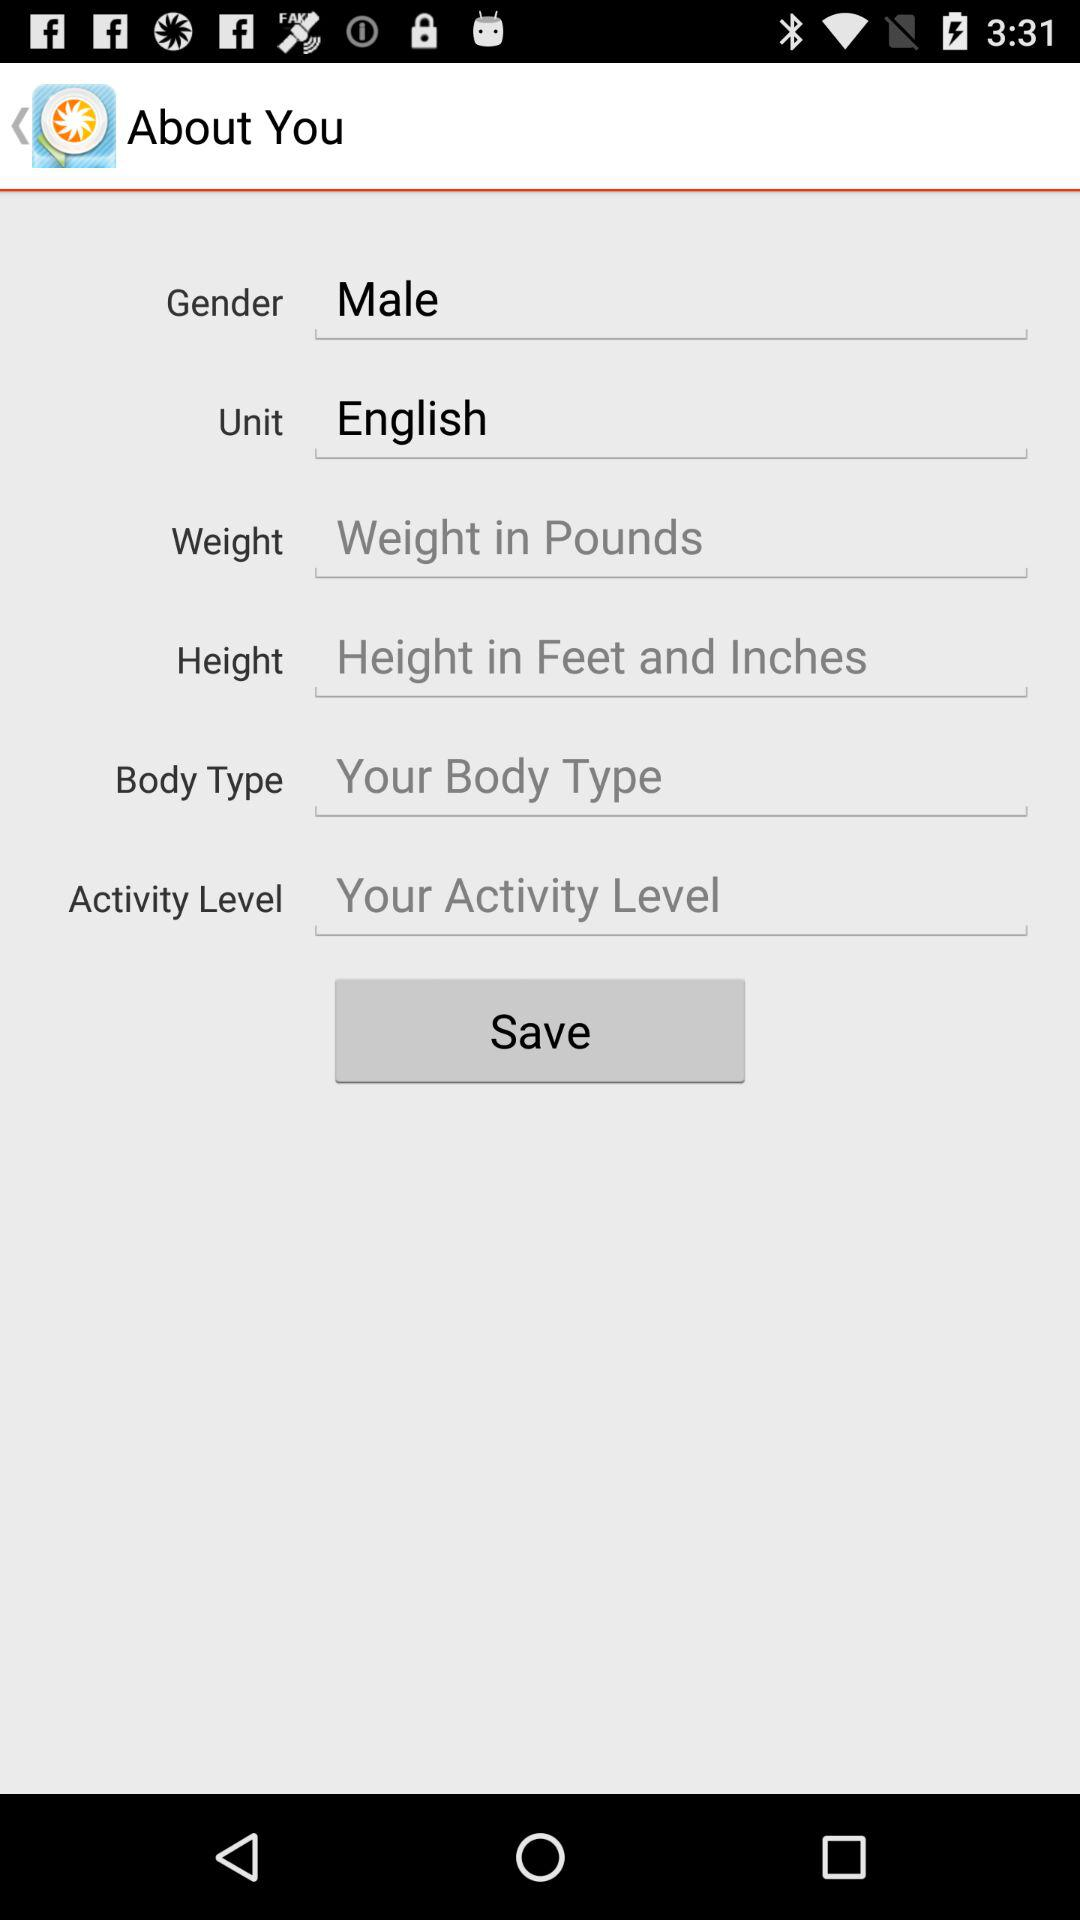What is the selected gender? The selected gender is male. 